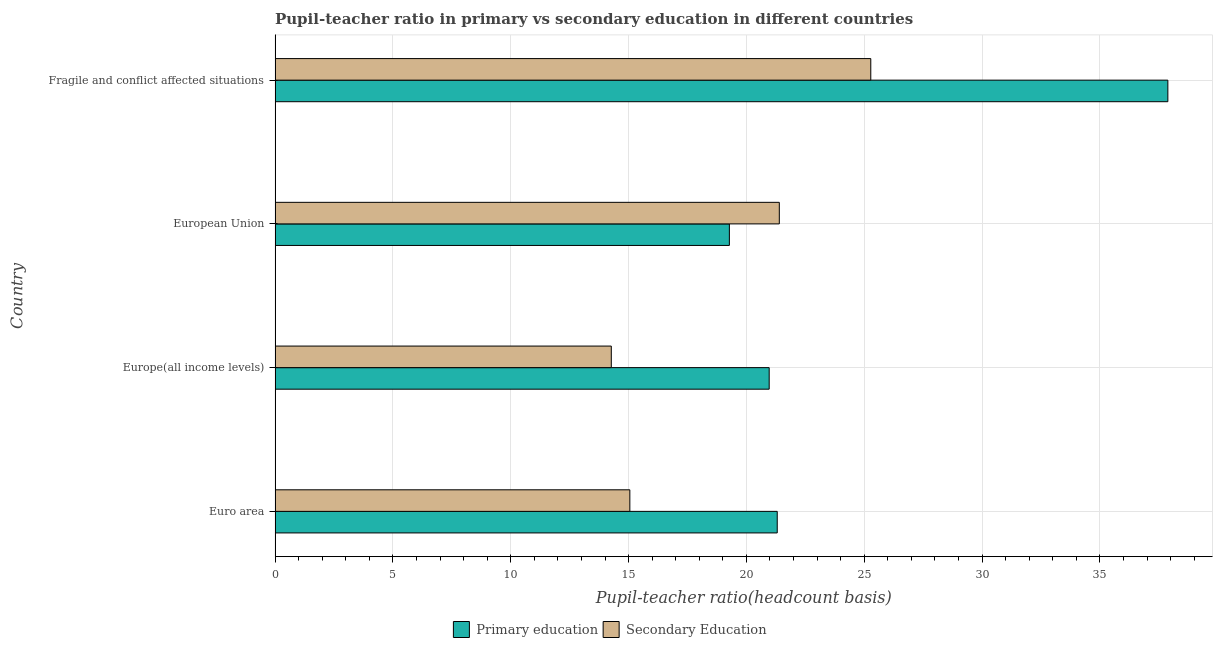How many different coloured bars are there?
Offer a very short reply. 2. How many groups of bars are there?
Provide a short and direct response. 4. Are the number of bars on each tick of the Y-axis equal?
Your answer should be compact. Yes. How many bars are there on the 1st tick from the bottom?
Give a very brief answer. 2. What is the label of the 1st group of bars from the top?
Provide a succinct answer. Fragile and conflict affected situations. What is the pupil teacher ratio on secondary education in Fragile and conflict affected situations?
Keep it short and to the point. 25.28. Across all countries, what is the maximum pupil-teacher ratio in primary education?
Give a very brief answer. 37.88. Across all countries, what is the minimum pupil-teacher ratio in primary education?
Keep it short and to the point. 19.28. In which country was the pupil teacher ratio on secondary education maximum?
Your response must be concise. Fragile and conflict affected situations. In which country was the pupil-teacher ratio in primary education minimum?
Ensure brevity in your answer.  European Union. What is the total pupil-teacher ratio in primary education in the graph?
Give a very brief answer. 99.44. What is the difference between the pupil teacher ratio on secondary education in Euro area and that in European Union?
Provide a short and direct response. -6.34. What is the difference between the pupil teacher ratio on secondary education in Europe(all income levels) and the pupil-teacher ratio in primary education in European Union?
Make the answer very short. -5.01. What is the average pupil teacher ratio on secondary education per country?
Provide a short and direct response. 19. What is the difference between the pupil-teacher ratio in primary education and pupil teacher ratio on secondary education in Fragile and conflict affected situations?
Give a very brief answer. 12.61. In how many countries, is the pupil teacher ratio on secondary education greater than 36 ?
Make the answer very short. 0. What is the ratio of the pupil teacher ratio on secondary education in Euro area to that in Fragile and conflict affected situations?
Offer a very short reply. 0.6. Is the difference between the pupil-teacher ratio in primary education in Euro area and European Union greater than the difference between the pupil teacher ratio on secondary education in Euro area and European Union?
Your answer should be compact. Yes. What is the difference between the highest and the second highest pupil teacher ratio on secondary education?
Provide a short and direct response. 3.88. What is the difference between the highest and the lowest pupil teacher ratio on secondary education?
Provide a succinct answer. 11.01. In how many countries, is the pupil-teacher ratio in primary education greater than the average pupil-teacher ratio in primary education taken over all countries?
Offer a very short reply. 1. Is the sum of the pupil-teacher ratio in primary education in Euro area and Europe(all income levels) greater than the maximum pupil teacher ratio on secondary education across all countries?
Your answer should be compact. Yes. What does the 1st bar from the top in Euro area represents?
Keep it short and to the point. Secondary Education. Are all the bars in the graph horizontal?
Keep it short and to the point. Yes. What is the difference between two consecutive major ticks on the X-axis?
Your answer should be very brief. 5. Does the graph contain any zero values?
Your response must be concise. No. Does the graph contain grids?
Your answer should be very brief. Yes. How many legend labels are there?
Your response must be concise. 2. How are the legend labels stacked?
Provide a succinct answer. Horizontal. What is the title of the graph?
Provide a succinct answer. Pupil-teacher ratio in primary vs secondary education in different countries. Does "Depositors" appear as one of the legend labels in the graph?
Your answer should be very brief. No. What is the label or title of the X-axis?
Offer a terse response. Pupil-teacher ratio(headcount basis). What is the Pupil-teacher ratio(headcount basis) of Primary education in Euro area?
Your response must be concise. 21.31. What is the Pupil-teacher ratio(headcount basis) in Secondary Education in Euro area?
Provide a succinct answer. 15.05. What is the Pupil-teacher ratio(headcount basis) in Primary education in Europe(all income levels)?
Make the answer very short. 20.97. What is the Pupil-teacher ratio(headcount basis) in Secondary Education in Europe(all income levels)?
Make the answer very short. 14.27. What is the Pupil-teacher ratio(headcount basis) of Primary education in European Union?
Offer a very short reply. 19.28. What is the Pupil-teacher ratio(headcount basis) in Secondary Education in European Union?
Keep it short and to the point. 21.4. What is the Pupil-teacher ratio(headcount basis) of Primary education in Fragile and conflict affected situations?
Your answer should be compact. 37.88. What is the Pupil-teacher ratio(headcount basis) of Secondary Education in Fragile and conflict affected situations?
Provide a short and direct response. 25.28. Across all countries, what is the maximum Pupil-teacher ratio(headcount basis) in Primary education?
Provide a short and direct response. 37.88. Across all countries, what is the maximum Pupil-teacher ratio(headcount basis) in Secondary Education?
Your response must be concise. 25.28. Across all countries, what is the minimum Pupil-teacher ratio(headcount basis) of Primary education?
Ensure brevity in your answer.  19.28. Across all countries, what is the minimum Pupil-teacher ratio(headcount basis) of Secondary Education?
Keep it short and to the point. 14.27. What is the total Pupil-teacher ratio(headcount basis) of Primary education in the graph?
Your answer should be very brief. 99.44. What is the total Pupil-teacher ratio(headcount basis) in Secondary Education in the graph?
Your response must be concise. 76. What is the difference between the Pupil-teacher ratio(headcount basis) of Primary education in Euro area and that in Europe(all income levels)?
Offer a very short reply. 0.34. What is the difference between the Pupil-teacher ratio(headcount basis) of Secondary Education in Euro area and that in Europe(all income levels)?
Offer a very short reply. 0.79. What is the difference between the Pupil-teacher ratio(headcount basis) in Primary education in Euro area and that in European Union?
Keep it short and to the point. 2.03. What is the difference between the Pupil-teacher ratio(headcount basis) of Secondary Education in Euro area and that in European Union?
Keep it short and to the point. -6.34. What is the difference between the Pupil-teacher ratio(headcount basis) of Primary education in Euro area and that in Fragile and conflict affected situations?
Keep it short and to the point. -16.58. What is the difference between the Pupil-teacher ratio(headcount basis) of Secondary Education in Euro area and that in Fragile and conflict affected situations?
Ensure brevity in your answer.  -10.22. What is the difference between the Pupil-teacher ratio(headcount basis) in Primary education in Europe(all income levels) and that in European Union?
Offer a very short reply. 1.69. What is the difference between the Pupil-teacher ratio(headcount basis) of Secondary Education in Europe(all income levels) and that in European Union?
Offer a very short reply. -7.13. What is the difference between the Pupil-teacher ratio(headcount basis) of Primary education in Europe(all income levels) and that in Fragile and conflict affected situations?
Offer a very short reply. -16.92. What is the difference between the Pupil-teacher ratio(headcount basis) in Secondary Education in Europe(all income levels) and that in Fragile and conflict affected situations?
Keep it short and to the point. -11.01. What is the difference between the Pupil-teacher ratio(headcount basis) of Primary education in European Union and that in Fragile and conflict affected situations?
Keep it short and to the point. -18.61. What is the difference between the Pupil-teacher ratio(headcount basis) of Secondary Education in European Union and that in Fragile and conflict affected situations?
Your response must be concise. -3.88. What is the difference between the Pupil-teacher ratio(headcount basis) of Primary education in Euro area and the Pupil-teacher ratio(headcount basis) of Secondary Education in Europe(all income levels)?
Make the answer very short. 7.04. What is the difference between the Pupil-teacher ratio(headcount basis) in Primary education in Euro area and the Pupil-teacher ratio(headcount basis) in Secondary Education in European Union?
Provide a succinct answer. -0.09. What is the difference between the Pupil-teacher ratio(headcount basis) in Primary education in Euro area and the Pupil-teacher ratio(headcount basis) in Secondary Education in Fragile and conflict affected situations?
Keep it short and to the point. -3.97. What is the difference between the Pupil-teacher ratio(headcount basis) of Primary education in Europe(all income levels) and the Pupil-teacher ratio(headcount basis) of Secondary Education in European Union?
Give a very brief answer. -0.43. What is the difference between the Pupil-teacher ratio(headcount basis) of Primary education in Europe(all income levels) and the Pupil-teacher ratio(headcount basis) of Secondary Education in Fragile and conflict affected situations?
Keep it short and to the point. -4.31. What is the difference between the Pupil-teacher ratio(headcount basis) of Primary education in European Union and the Pupil-teacher ratio(headcount basis) of Secondary Education in Fragile and conflict affected situations?
Your response must be concise. -6. What is the average Pupil-teacher ratio(headcount basis) of Primary education per country?
Make the answer very short. 24.86. What is the average Pupil-teacher ratio(headcount basis) of Secondary Education per country?
Provide a succinct answer. 19. What is the difference between the Pupil-teacher ratio(headcount basis) in Primary education and Pupil-teacher ratio(headcount basis) in Secondary Education in Euro area?
Your answer should be very brief. 6.25. What is the difference between the Pupil-teacher ratio(headcount basis) in Primary education and Pupil-teacher ratio(headcount basis) in Secondary Education in Europe(all income levels)?
Keep it short and to the point. 6.7. What is the difference between the Pupil-teacher ratio(headcount basis) in Primary education and Pupil-teacher ratio(headcount basis) in Secondary Education in European Union?
Offer a very short reply. -2.12. What is the difference between the Pupil-teacher ratio(headcount basis) of Primary education and Pupil-teacher ratio(headcount basis) of Secondary Education in Fragile and conflict affected situations?
Your answer should be compact. 12.61. What is the ratio of the Pupil-teacher ratio(headcount basis) in Primary education in Euro area to that in Europe(all income levels)?
Provide a succinct answer. 1.02. What is the ratio of the Pupil-teacher ratio(headcount basis) in Secondary Education in Euro area to that in Europe(all income levels)?
Keep it short and to the point. 1.06. What is the ratio of the Pupil-teacher ratio(headcount basis) of Primary education in Euro area to that in European Union?
Keep it short and to the point. 1.11. What is the ratio of the Pupil-teacher ratio(headcount basis) of Secondary Education in Euro area to that in European Union?
Your answer should be very brief. 0.7. What is the ratio of the Pupil-teacher ratio(headcount basis) in Primary education in Euro area to that in Fragile and conflict affected situations?
Keep it short and to the point. 0.56. What is the ratio of the Pupil-teacher ratio(headcount basis) in Secondary Education in Euro area to that in Fragile and conflict affected situations?
Provide a succinct answer. 0.6. What is the ratio of the Pupil-teacher ratio(headcount basis) in Primary education in Europe(all income levels) to that in European Union?
Your answer should be very brief. 1.09. What is the ratio of the Pupil-teacher ratio(headcount basis) of Secondary Education in Europe(all income levels) to that in European Union?
Your answer should be very brief. 0.67. What is the ratio of the Pupil-teacher ratio(headcount basis) of Primary education in Europe(all income levels) to that in Fragile and conflict affected situations?
Your answer should be compact. 0.55. What is the ratio of the Pupil-teacher ratio(headcount basis) in Secondary Education in Europe(all income levels) to that in Fragile and conflict affected situations?
Make the answer very short. 0.56. What is the ratio of the Pupil-teacher ratio(headcount basis) in Primary education in European Union to that in Fragile and conflict affected situations?
Your response must be concise. 0.51. What is the ratio of the Pupil-teacher ratio(headcount basis) of Secondary Education in European Union to that in Fragile and conflict affected situations?
Make the answer very short. 0.85. What is the difference between the highest and the second highest Pupil-teacher ratio(headcount basis) in Primary education?
Provide a succinct answer. 16.58. What is the difference between the highest and the second highest Pupil-teacher ratio(headcount basis) of Secondary Education?
Provide a short and direct response. 3.88. What is the difference between the highest and the lowest Pupil-teacher ratio(headcount basis) of Primary education?
Provide a succinct answer. 18.61. What is the difference between the highest and the lowest Pupil-teacher ratio(headcount basis) in Secondary Education?
Give a very brief answer. 11.01. 